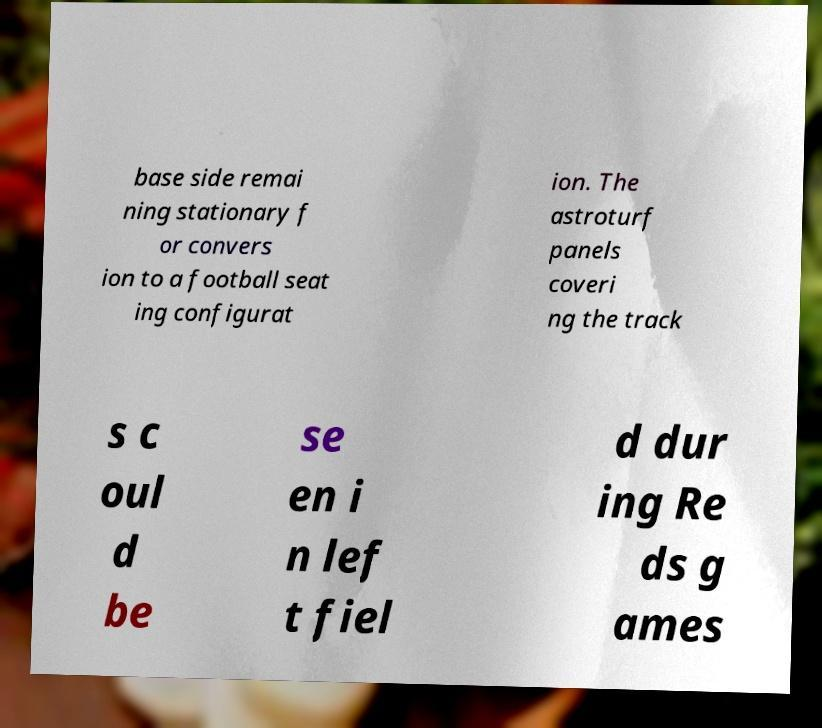Please identify and transcribe the text found in this image. base side remai ning stationary f or convers ion to a football seat ing configurat ion. The astroturf panels coveri ng the track s c oul d be se en i n lef t fiel d dur ing Re ds g ames 